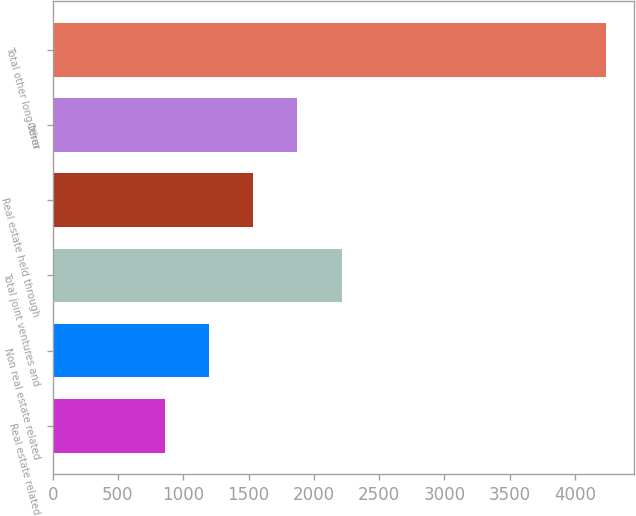Convert chart. <chart><loc_0><loc_0><loc_500><loc_500><bar_chart><fcel>Real estate related<fcel>Non real estate related<fcel>Total joint ventures and<fcel>Real estate held through<fcel>Other<fcel>Total other long-term<nl><fcel>861<fcel>1198.8<fcel>2212.2<fcel>1536.6<fcel>1874.4<fcel>4239<nl></chart> 